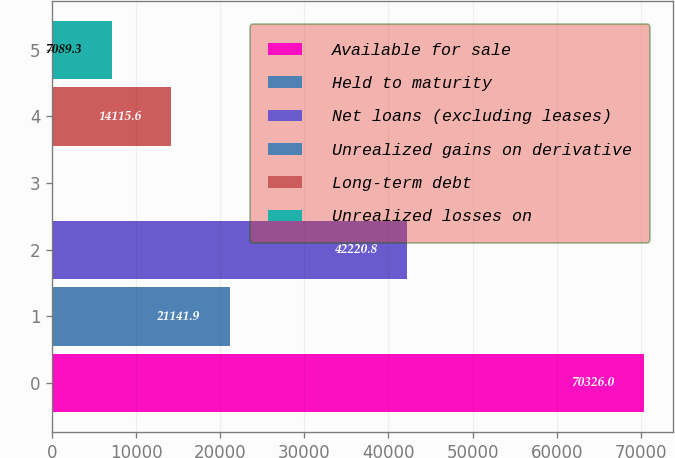<chart> <loc_0><loc_0><loc_500><loc_500><bar_chart><fcel>Available for sale<fcel>Held to maturity<fcel>Net loans (excluding leases)<fcel>Unrealized gains on derivative<fcel>Long-term debt<fcel>Unrealized losses on<nl><fcel>70326<fcel>21141.9<fcel>42220.8<fcel>63<fcel>14115.6<fcel>7089.3<nl></chart> 